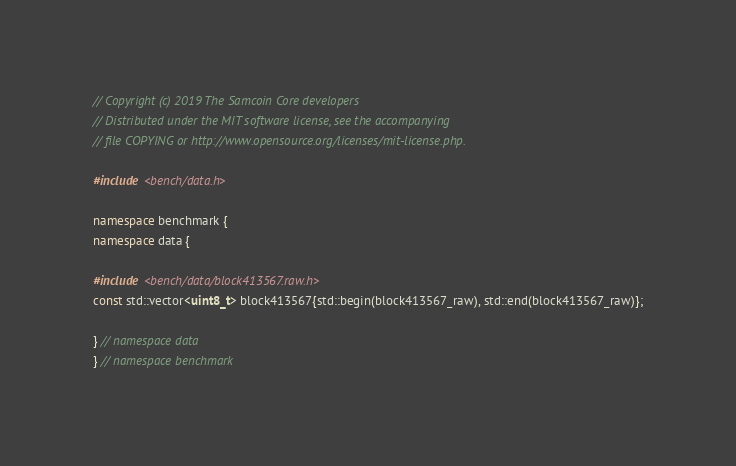Convert code to text. <code><loc_0><loc_0><loc_500><loc_500><_C++_>// Copyright (c) 2019 The Samcoin Core developers
// Distributed under the MIT software license, see the accompanying
// file COPYING or http://www.opensource.org/licenses/mit-license.php.

#include <bench/data.h>

namespace benchmark {
namespace data {

#include <bench/data/block413567.raw.h>
const std::vector<uint8_t> block413567{std::begin(block413567_raw), std::end(block413567_raw)};

} // namespace data
} // namespace benchmark
</code> 